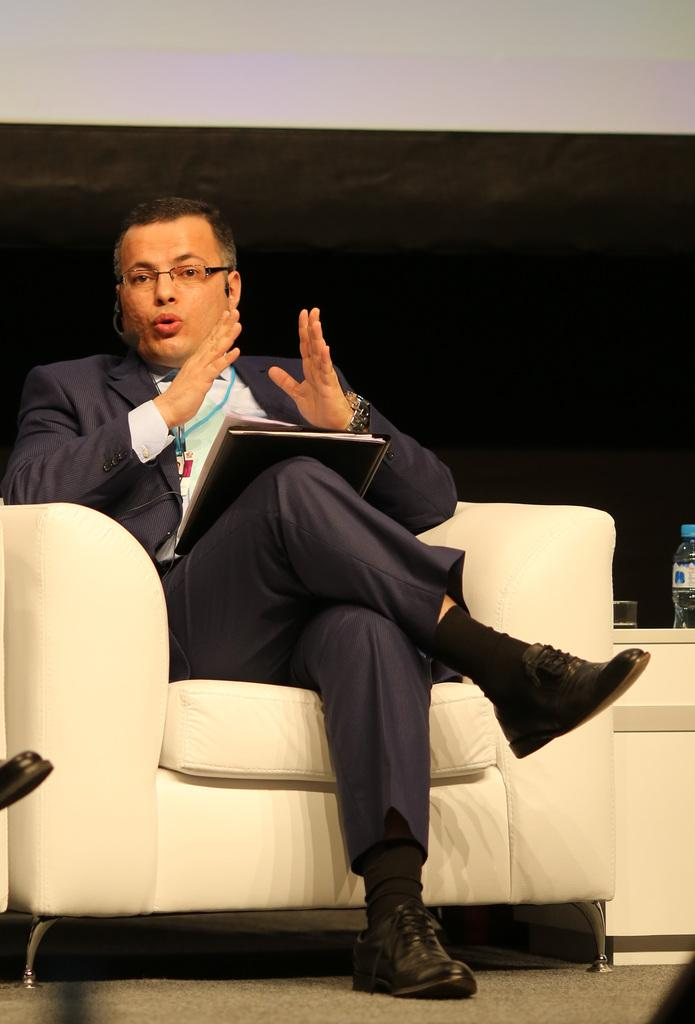What is the person in the image doing? The person is sitting on a chair and talking. What is the person holding in the image? The person is holding a book. What can be seen in the background of the image? There is a wall in the background of the image. What else is present in the image besides the person and the wall? There is a bottle in the image. How many pigs are visible in the image? There are no pigs present in the image. What type of scene is being depicted in the image? The image does not depict a specific scene; it simply shows a person sitting on a chair, holding a book, and talking. 